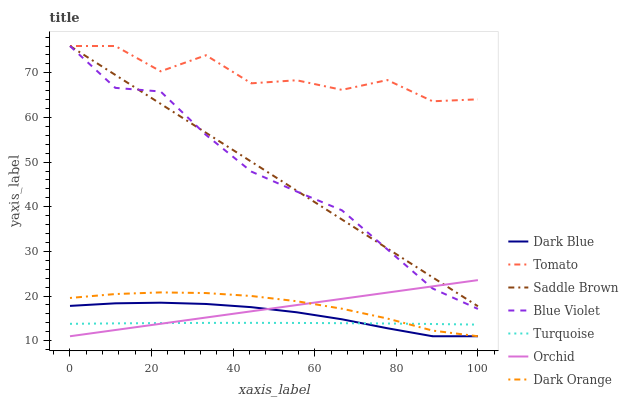Does Turquoise have the minimum area under the curve?
Answer yes or no. Yes. Does Tomato have the maximum area under the curve?
Answer yes or no. Yes. Does Dark Orange have the minimum area under the curve?
Answer yes or no. No. Does Dark Orange have the maximum area under the curve?
Answer yes or no. No. Is Orchid the smoothest?
Answer yes or no. Yes. Is Tomato the roughest?
Answer yes or no. Yes. Is Dark Orange the smoothest?
Answer yes or no. No. Is Dark Orange the roughest?
Answer yes or no. No. Does Dark Orange have the lowest value?
Answer yes or no. Yes. Does Turquoise have the lowest value?
Answer yes or no. No. Does Blue Violet have the highest value?
Answer yes or no. Yes. Does Dark Orange have the highest value?
Answer yes or no. No. Is Dark Orange less than Tomato?
Answer yes or no. Yes. Is Saddle Brown greater than Dark Blue?
Answer yes or no. Yes. Does Orchid intersect Dark Blue?
Answer yes or no. Yes. Is Orchid less than Dark Blue?
Answer yes or no. No. Is Orchid greater than Dark Blue?
Answer yes or no. No. Does Dark Orange intersect Tomato?
Answer yes or no. No. 